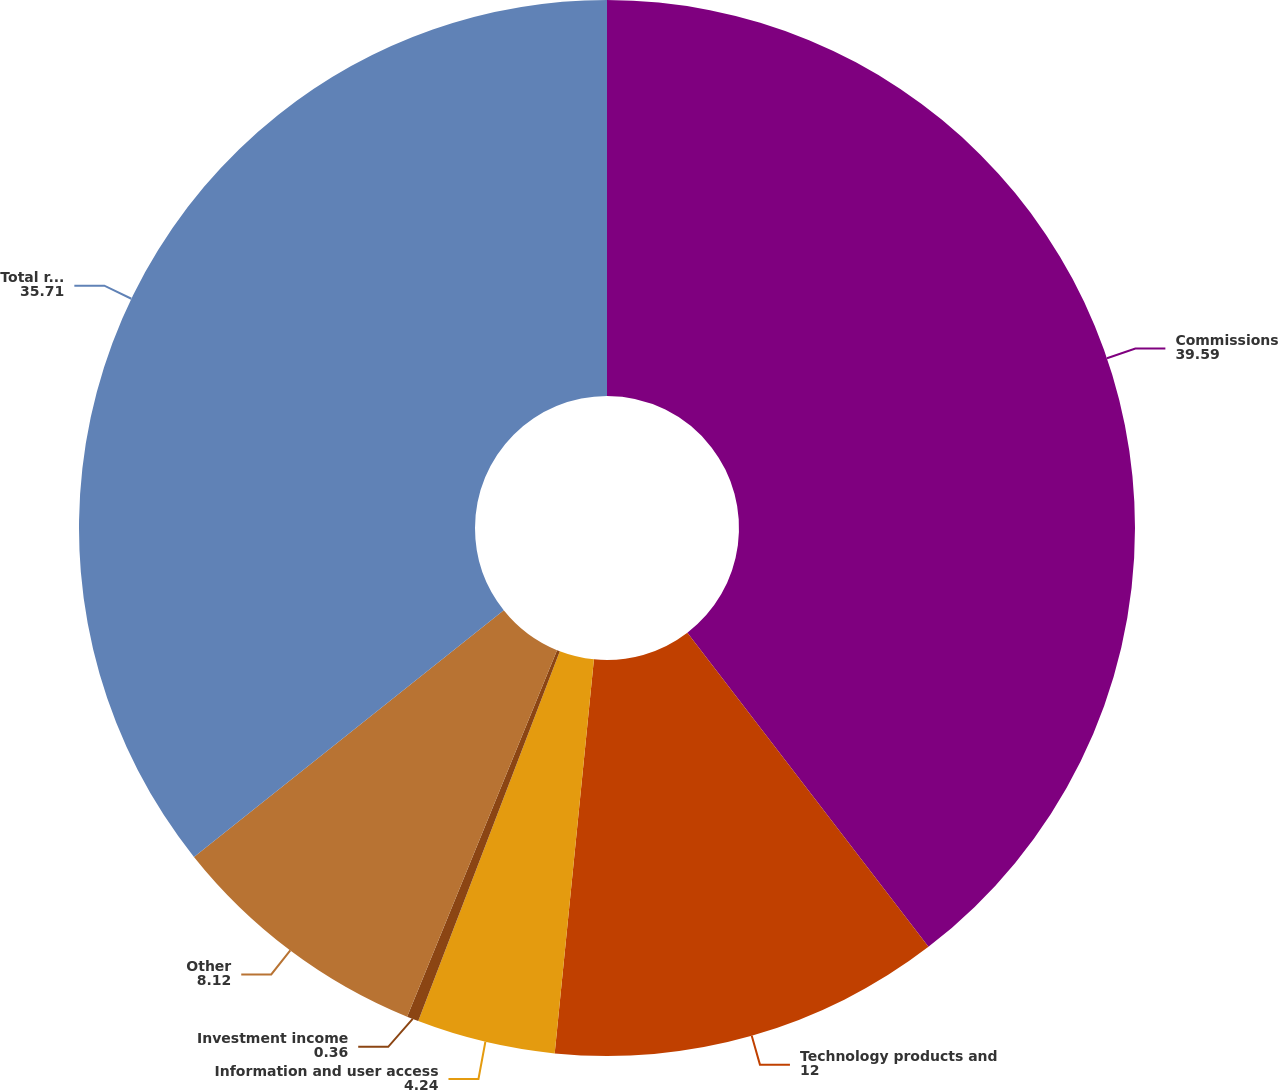Convert chart to OTSL. <chart><loc_0><loc_0><loc_500><loc_500><pie_chart><fcel>Commissions<fcel>Technology products and<fcel>Information and user access<fcel>Investment income<fcel>Other<fcel>Total revenues<nl><fcel>39.59%<fcel>12.0%<fcel>4.24%<fcel>0.36%<fcel>8.12%<fcel>35.71%<nl></chart> 